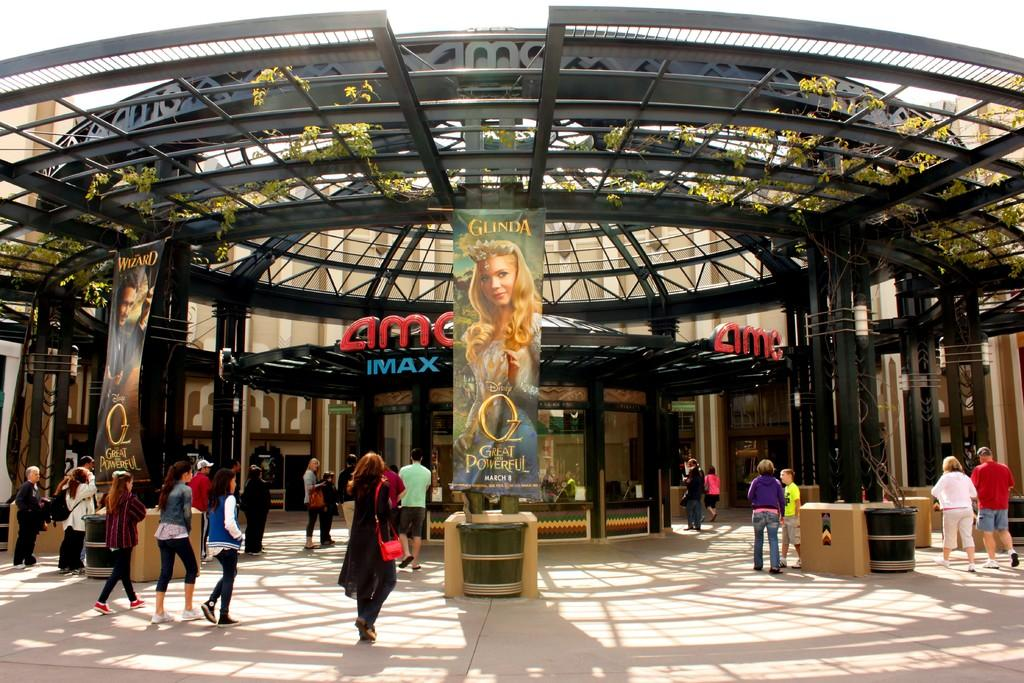What can be seen hanging in the image? There are banners in the image. What objects are present for waste disposal? There are dustbins in the image. What are the people in the image doing? There are people walking in the image. What is written on the metal rod in the background? There are letters on a metal rod in the background of the image. What type of structures can be seen in the distance? There are buildings in the background of the image. What type of vegetation is visible in the background? There are plants in the background of the image. What type of coach can be seen driving through the image? There is no coach present in the image. How does the earth appear in the image? The image does not show the earth; it is a scene with banners, dustbins, people walking, letters on a metal rod, buildings, and plants in the background. 